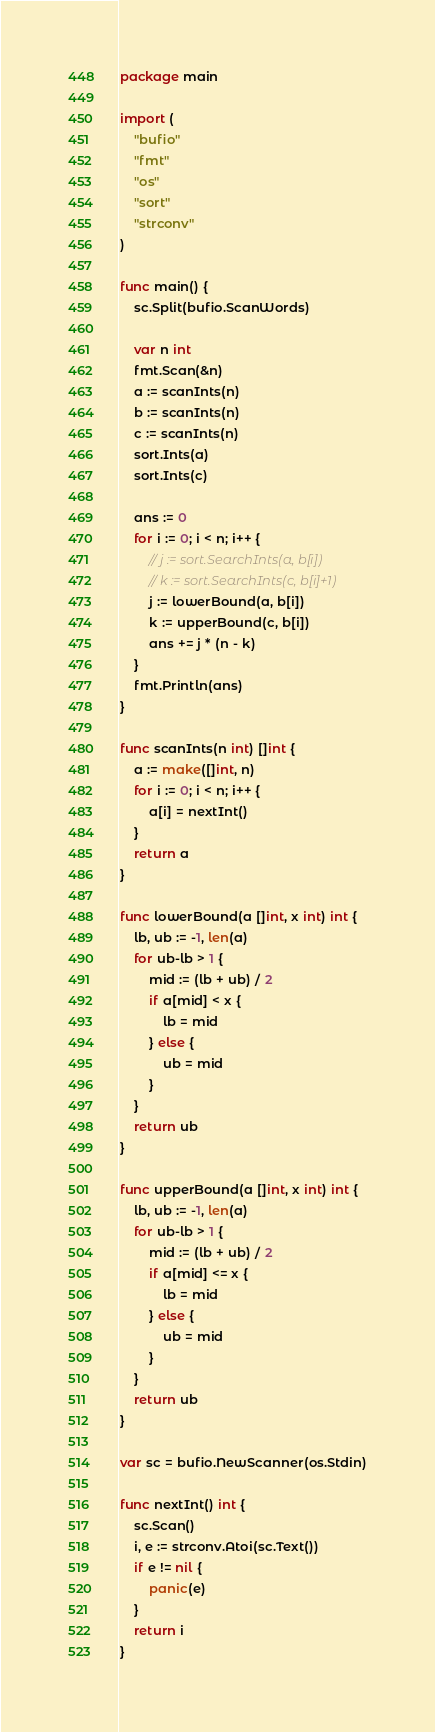Convert code to text. <code><loc_0><loc_0><loc_500><loc_500><_Go_>package main

import (
	"bufio"
	"fmt"
	"os"
	"sort"
	"strconv"
)

func main() {
	sc.Split(bufio.ScanWords)

	var n int
	fmt.Scan(&n)
	a := scanInts(n)
	b := scanInts(n)
	c := scanInts(n)
	sort.Ints(a)
	sort.Ints(c)

	ans := 0
	for i := 0; i < n; i++ {
		// j := sort.SearchInts(a, b[i])
		// k := sort.SearchInts(c, b[i]+1)
		j := lowerBound(a, b[i])
		k := upperBound(c, b[i])
		ans += j * (n - k)
	}
	fmt.Println(ans)
}

func scanInts(n int) []int {
	a := make([]int, n)
	for i := 0; i < n; i++ {
		a[i] = nextInt()
	}
	return a
}

func lowerBound(a []int, x int) int {
	lb, ub := -1, len(a)
	for ub-lb > 1 {
		mid := (lb + ub) / 2
		if a[mid] < x {
			lb = mid
		} else {
			ub = mid
		}
	}
	return ub
}

func upperBound(a []int, x int) int {
	lb, ub := -1, len(a)
	for ub-lb > 1 {
		mid := (lb + ub) / 2
		if a[mid] <= x {
			lb = mid
		} else {
			ub = mid
		}
	}
	return ub
}

var sc = bufio.NewScanner(os.Stdin)

func nextInt() int {
	sc.Scan()
	i, e := strconv.Atoi(sc.Text())
	if e != nil {
		panic(e)
	}
	return i
}
</code> 